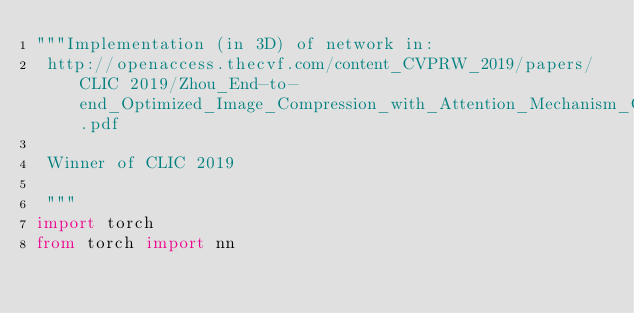<code> <loc_0><loc_0><loc_500><loc_500><_Python_>"""Implementation (in 3D) of network in:
 http://openaccess.thecvf.com/content_CVPRW_2019/papers/CLIC 2019/Zhou_End-to-end_Optimized_Image_Compression_with_Attention_Mechanism_CVPRW_2019_paper.pdf

 Winner of CLIC 2019

 """
import torch
from torch import nn</code> 